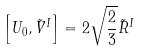Convert formula to latex. <formula><loc_0><loc_0><loc_500><loc_500>\left [ U _ { 0 } , \tilde { V } ^ { I } \right ] = 2 \sqrt { \frac { 2 } { 3 } } \tilde { R } ^ { I }</formula> 